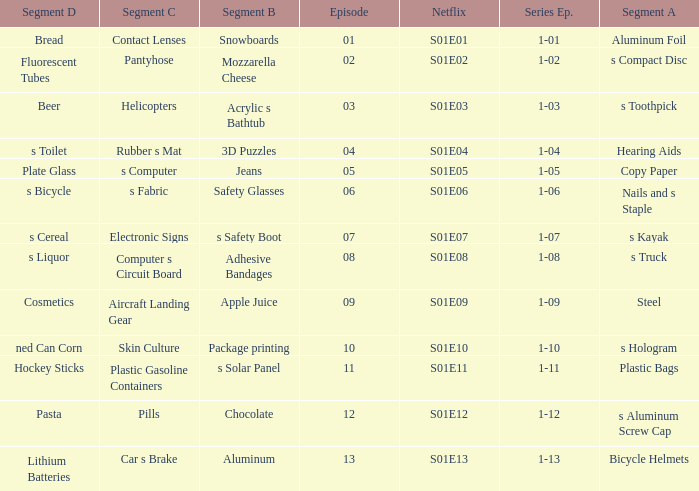For a segment D of pasta, what is the segment B? Chocolate. 